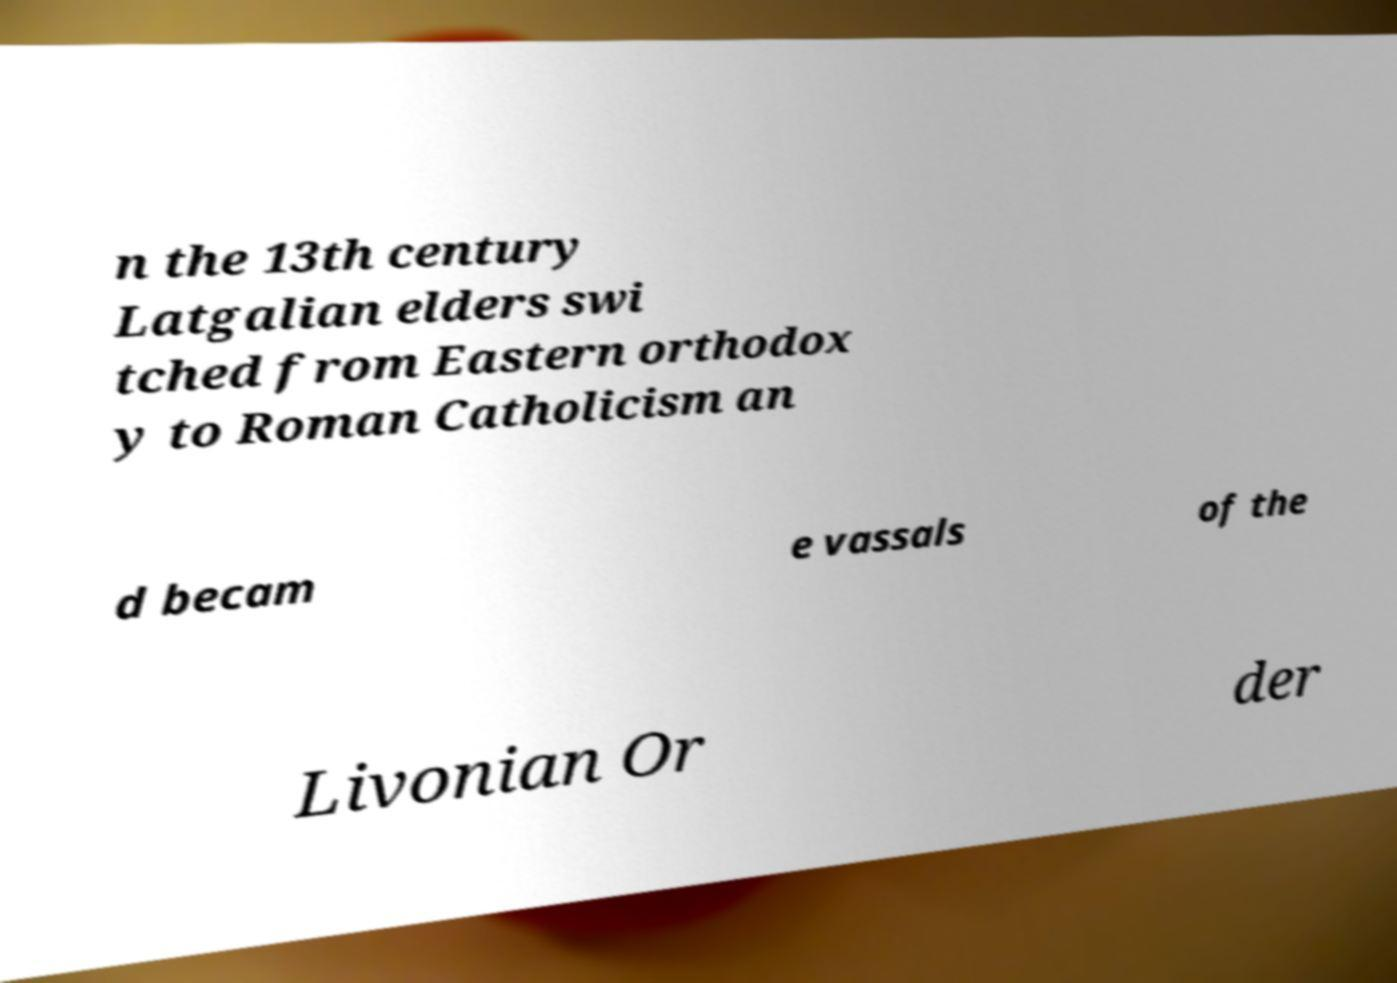Please read and relay the text visible in this image. What does it say? n the 13th century Latgalian elders swi tched from Eastern orthodox y to Roman Catholicism an d becam e vassals of the Livonian Or der 